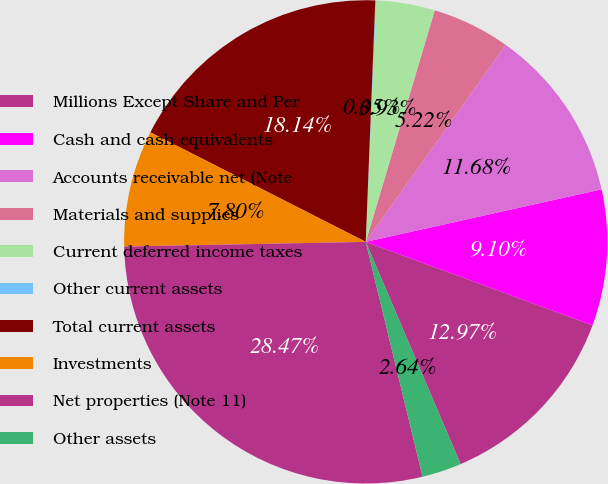Convert chart to OTSL. <chart><loc_0><loc_0><loc_500><loc_500><pie_chart><fcel>Millions Except Share and Per<fcel>Cash and cash equivalents<fcel>Accounts receivable net (Note<fcel>Materials and supplies<fcel>Current deferred income taxes<fcel>Other current assets<fcel>Total current assets<fcel>Investments<fcel>Net properties (Note 11)<fcel>Other assets<nl><fcel>12.97%<fcel>9.1%<fcel>11.68%<fcel>5.22%<fcel>3.93%<fcel>0.05%<fcel>18.14%<fcel>7.8%<fcel>28.47%<fcel>2.64%<nl></chart> 